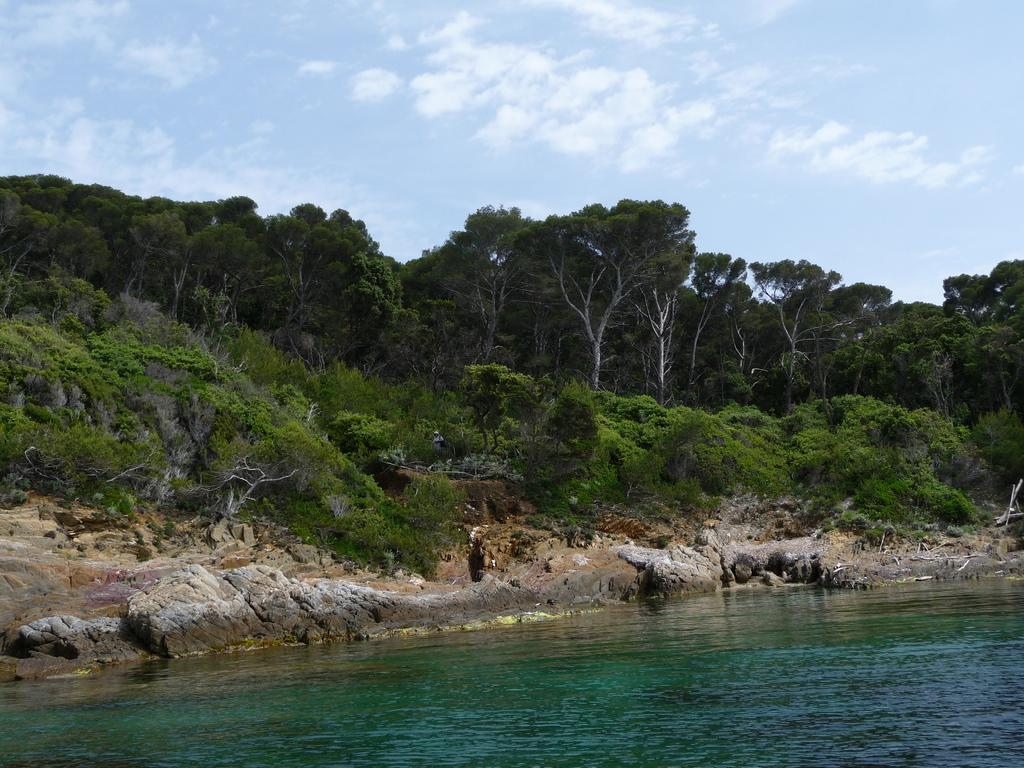What is the primary element visible in the image? There is water in the image. What type of natural vegetation can be seen in the image? There are trees in the image. What other objects are present in the image? There are rocks in the image. What can be seen in the background of the image? The sky is visible in the background of the image. What year is depicted in the image? The image does not depict a specific year; it is a natural scene with water, trees, rocks, and the sky. 